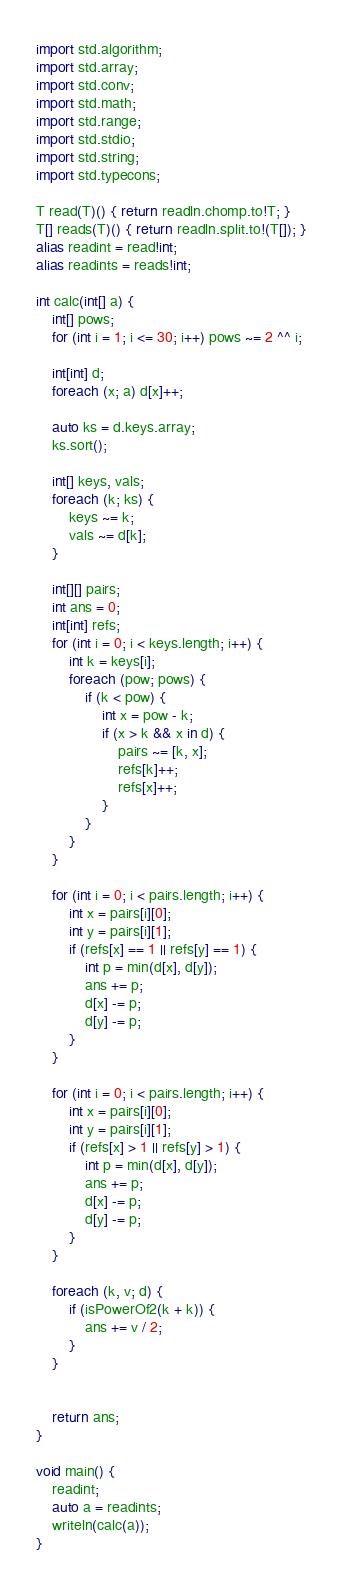<code> <loc_0><loc_0><loc_500><loc_500><_D_>import std.algorithm;
import std.array;
import std.conv;
import std.math;
import std.range;
import std.stdio;
import std.string;
import std.typecons;

T read(T)() { return readln.chomp.to!T; }
T[] reads(T)() { return readln.split.to!(T[]); }
alias readint = read!int;
alias readints = reads!int;

int calc(int[] a) {
    int[] pows;
    for (int i = 1; i <= 30; i++) pows ~= 2 ^^ i;

    int[int] d;
    foreach (x; a) d[x]++;

    auto ks = d.keys.array;
    ks.sort();

    int[] keys, vals;
    foreach (k; ks) {
        keys ~= k;
        vals ~= d[k];
    }

    int[][] pairs;
    int ans = 0;
    int[int] refs;
    for (int i = 0; i < keys.length; i++) {
        int k = keys[i];
        foreach (pow; pows) {
            if (k < pow) {
                int x = pow - k;
                if (x > k && x in d) {
                    pairs ~= [k, x];
                    refs[k]++;
                    refs[x]++;
                }
            }
        }
    }

    for (int i = 0; i < pairs.length; i++) {
        int x = pairs[i][0];
        int y = pairs[i][1];
        if (refs[x] == 1 || refs[y] == 1) {
            int p = min(d[x], d[y]);
            ans += p;
            d[x] -= p;
            d[y] -= p;
        }
    }

    for (int i = 0; i < pairs.length; i++) {
        int x = pairs[i][0];
        int y = pairs[i][1];
        if (refs[x] > 1 || refs[y] > 1) {
            int p = min(d[x], d[y]);
            ans += p;
            d[x] -= p;
            d[y] -= p;
        }
    }

    foreach (k, v; d) {
        if (isPowerOf2(k + k)) {
            ans += v / 2;
        }
    }


    return ans;
}

void main() {
    readint;
    auto a = readints;
    writeln(calc(a));
}
</code> 